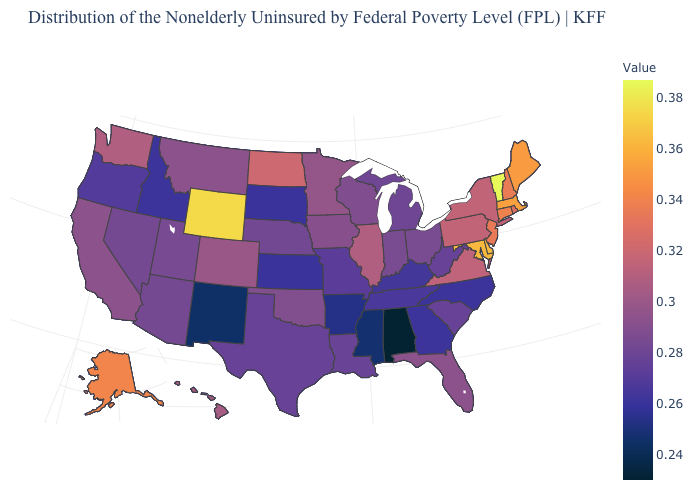Which states have the highest value in the USA?
Quick response, please. Vermont. Does Vermont have the highest value in the USA?
Quick response, please. Yes. Does Alabama have the lowest value in the USA?
Give a very brief answer. Yes. 